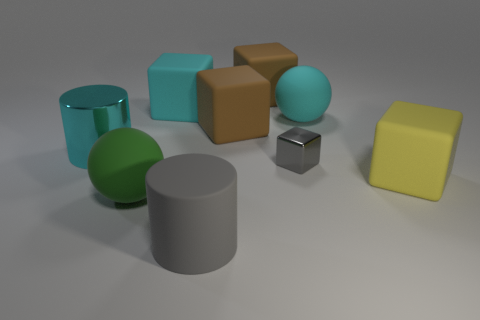Subtract all gray cubes. How many cubes are left? 4 Subtract all tiny shiny cubes. How many cubes are left? 4 Subtract all green blocks. Subtract all green balls. How many blocks are left? 5 Add 1 gray shiny blocks. How many objects exist? 10 Subtract all blocks. How many objects are left? 4 Add 4 gray objects. How many gray objects are left? 6 Add 8 small brown objects. How many small brown objects exist? 8 Subtract 1 cyan spheres. How many objects are left? 8 Subtract all big gray matte cylinders. Subtract all cyan rubber objects. How many objects are left? 6 